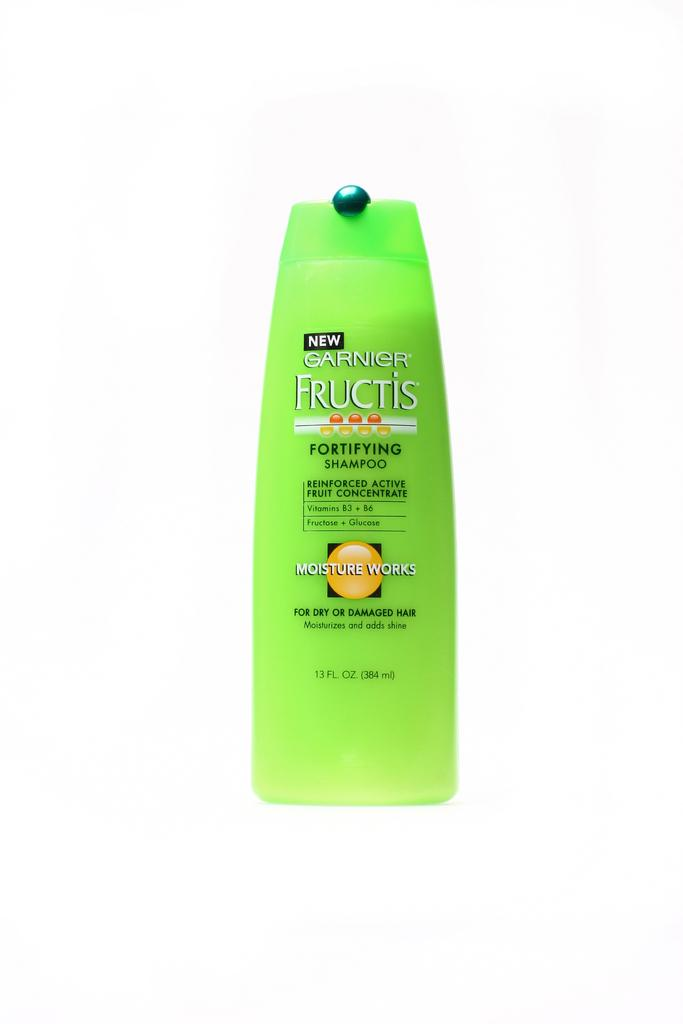<image>
Render a clear and concise summary of the photo. a shampoo bottle that has Garnier Fructis on it 